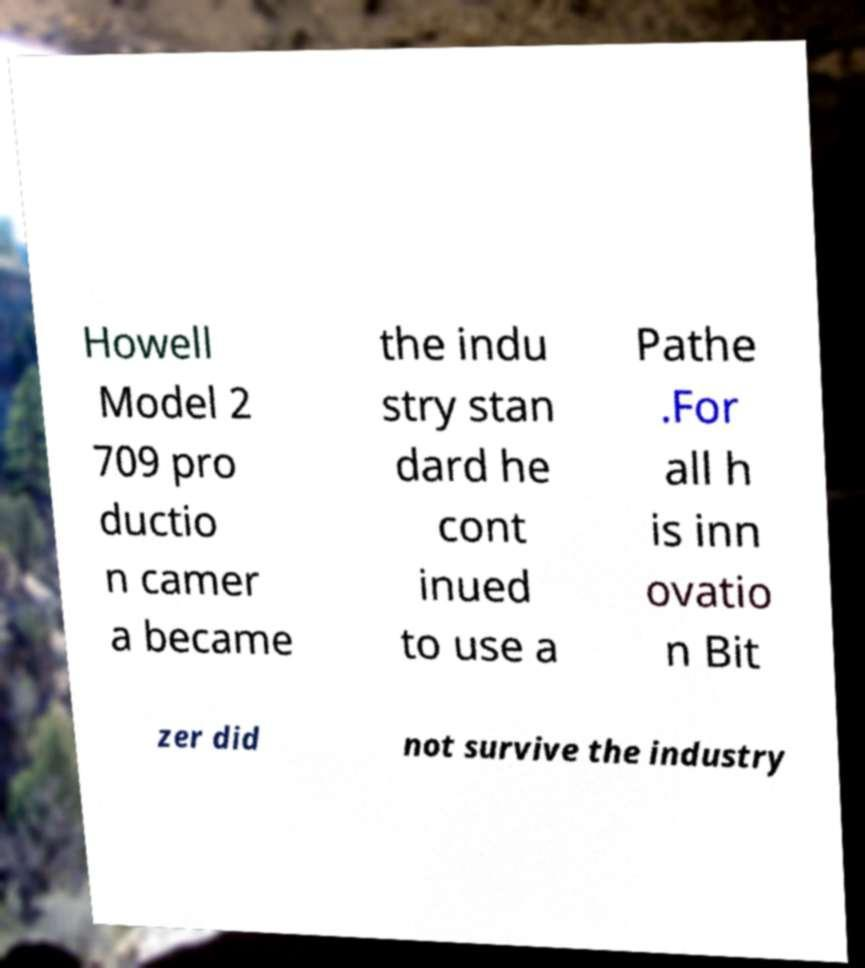Can you read and provide the text displayed in the image?This photo seems to have some interesting text. Can you extract and type it out for me? Howell Model 2 709 pro ductio n camer a became the indu stry stan dard he cont inued to use a Pathe .For all h is inn ovatio n Bit zer did not survive the industry 